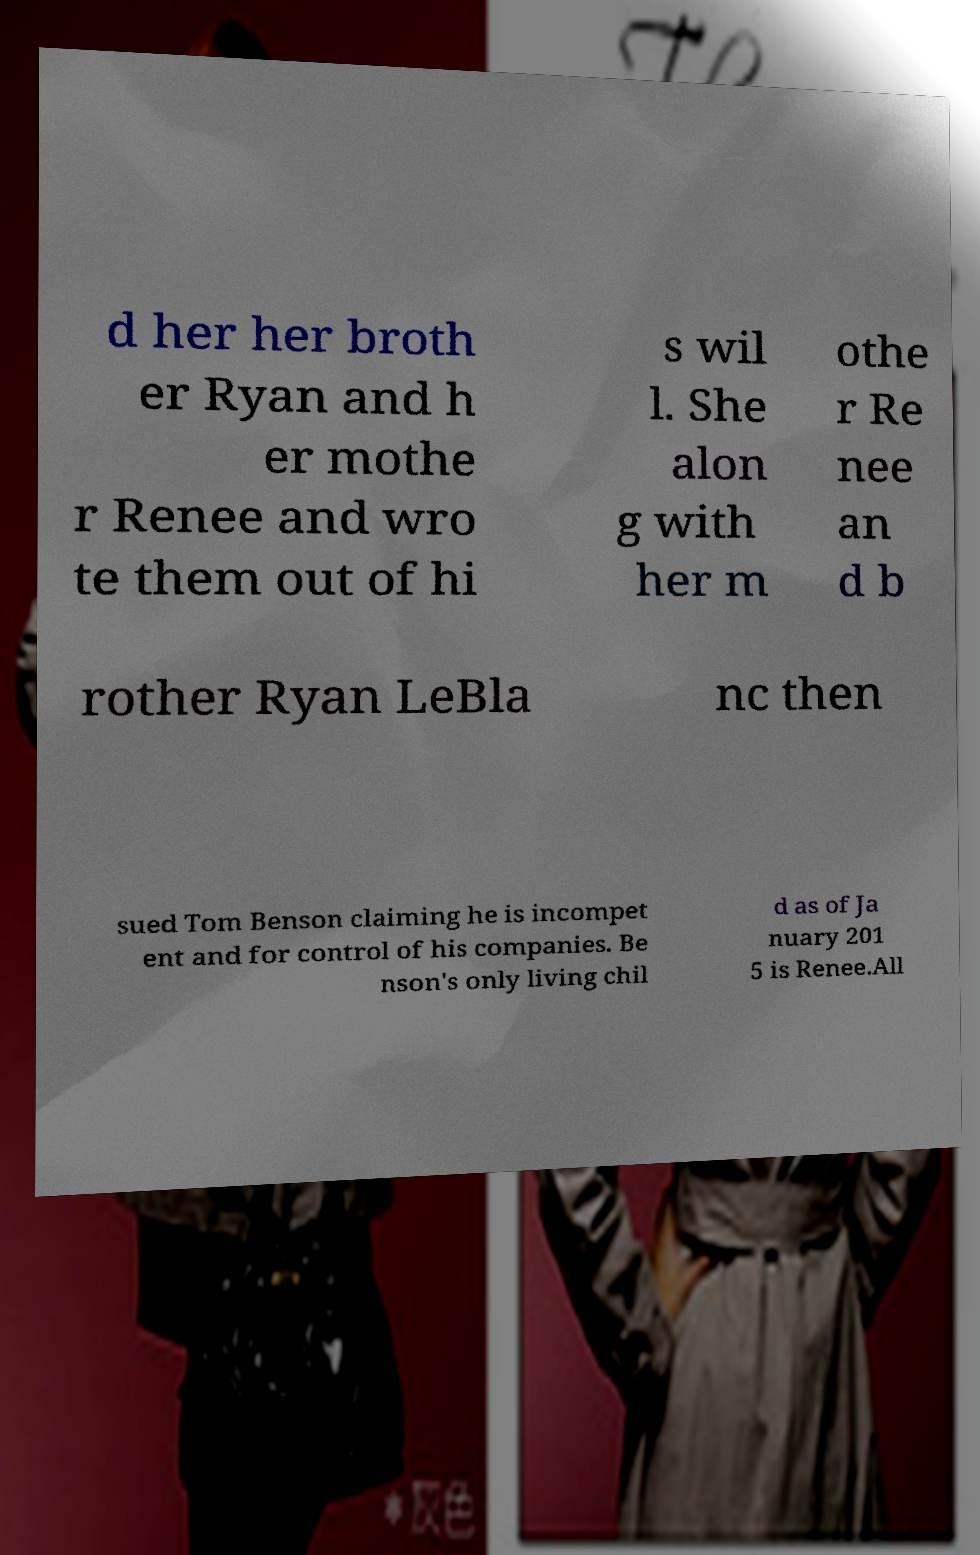There's text embedded in this image that I need extracted. Can you transcribe it verbatim? d her her broth er Ryan and h er mothe r Renee and wro te them out of hi s wil l. She alon g with her m othe r Re nee an d b rother Ryan LeBla nc then sued Tom Benson claiming he is incompet ent and for control of his companies. Be nson's only living chil d as of Ja nuary 201 5 is Renee.All 